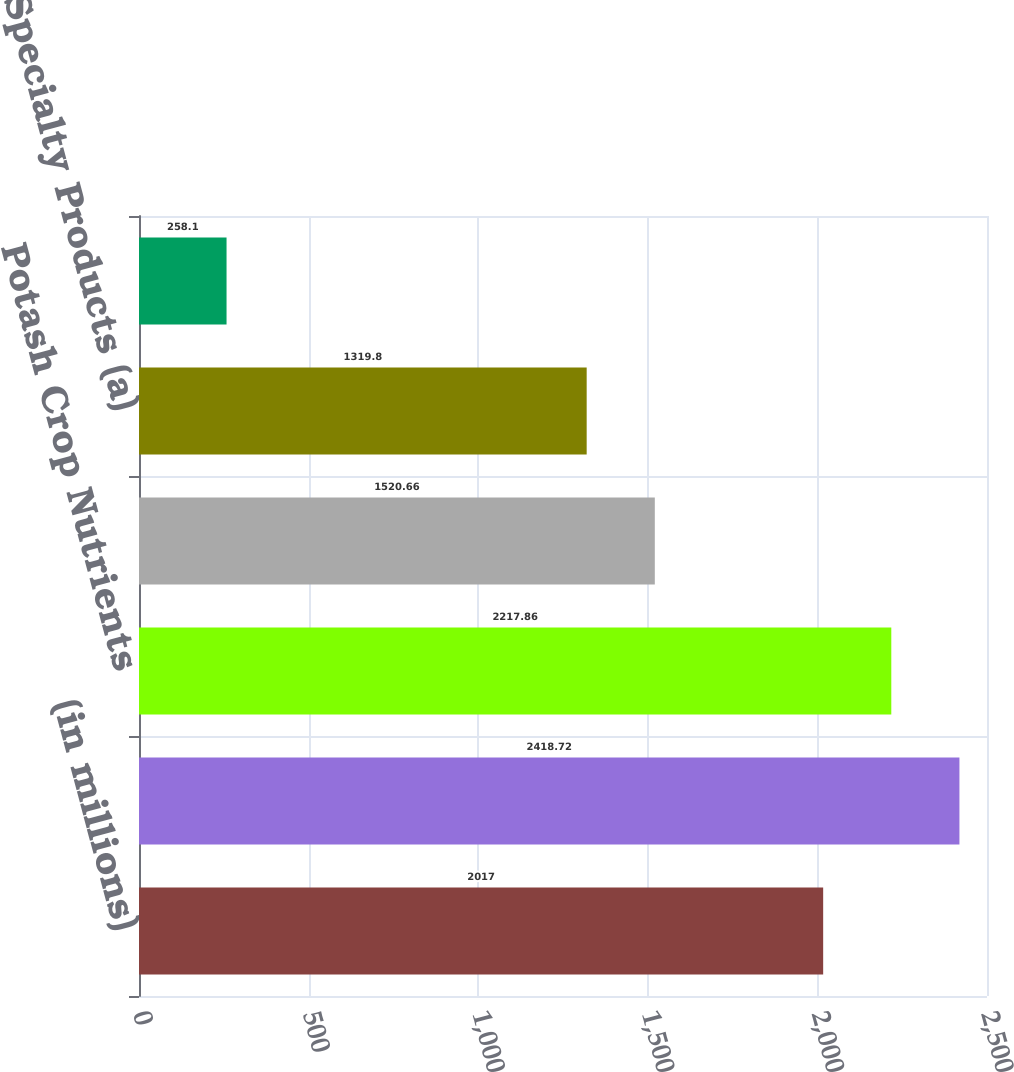Convert chart. <chart><loc_0><loc_0><loc_500><loc_500><bar_chart><fcel>(in millions)<fcel>Phosphate Crop Nutrients<fcel>Potash Crop Nutrients<fcel>Crop Nutrient Blends<fcel>Specialty Products (a)<fcel>Other (b)<nl><fcel>2017<fcel>2418.72<fcel>2217.86<fcel>1520.66<fcel>1319.8<fcel>258.1<nl></chart> 